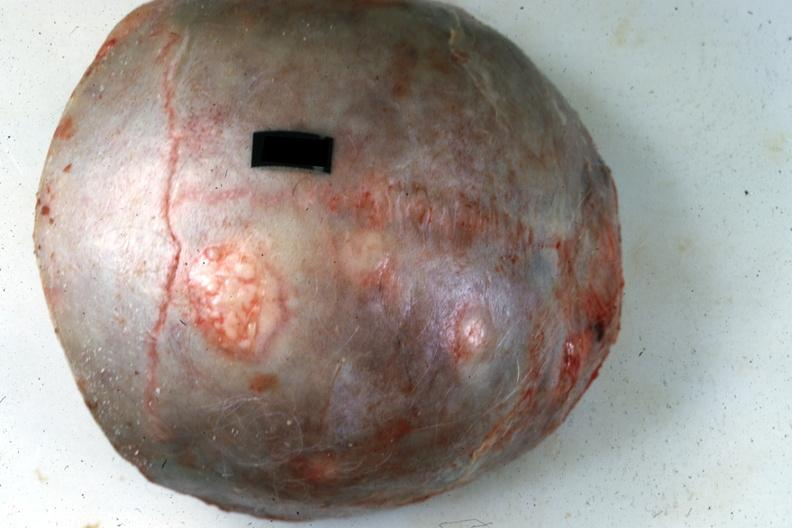does metastatic carcinoma lung show top of calvaria typical lesions source?
Answer the question using a single word or phrase. No 